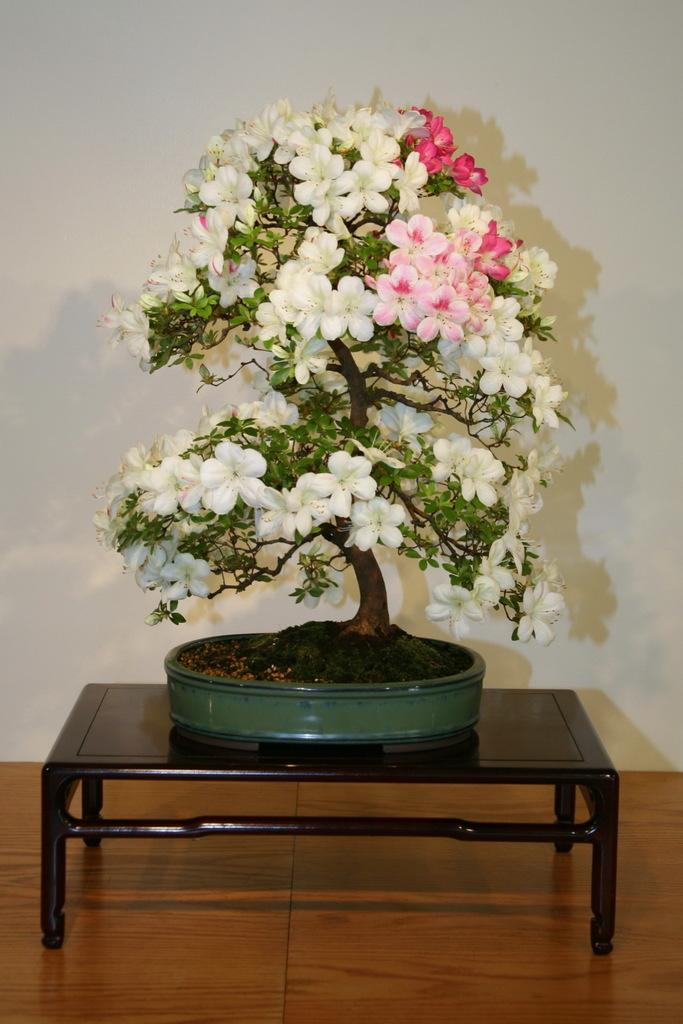What is the color of the wall in the image? The wall in the image is white. What object can be seen on the wall? There is no object visible on the wall in the image. What piece of furniture is present in the image? There is a small table in the image. What is placed on the table? There is a plant on the table. How many rabbits can be seen on the table in the image? There are no rabbits present on the table or in the image. 